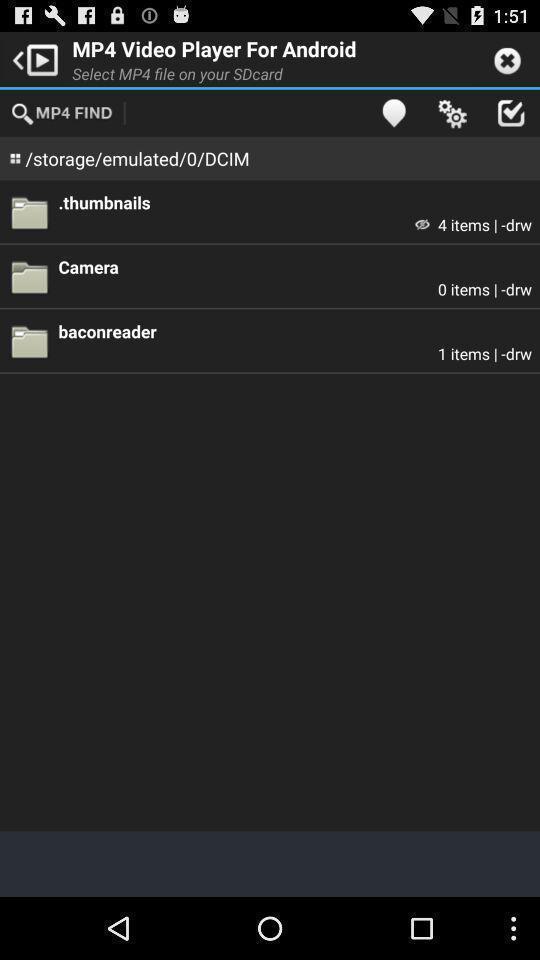Describe the content in this image. Screen displaying the list of items under music player app. 